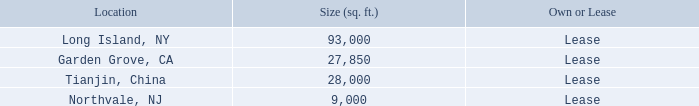Item 2. Properties
The Company operates out of several facilities located around the world. Each facility is used for manufacturing its products and for administrative activities. The following table presents the location, size and terms of ownership/occupation:
The Company’s facility located in Mitchel Field, Long Island, New York, is part of the building that the Company constructed in 1981 and expanded in 1988 on land leased from Nassau County. In January 1998, the Company sold this building and the related land lease to Reckson Associates Realty Corp. (“Reckson”), leasing back the space that it presently occupies.
The Company leased its manufacturing and office space from Reckson under an initial 11-year lease followed by two five-year renewal periods which ended in January 2019. On July 25, 2018, the Company signed an amendment to the lease with RA 55 CLB LLC (as successor-in-interest to Reckson) which extended the current lease terms ten years and eight months through September 30, 2029. Pursuant to the amendment to the lease agreement, the Company shall pay a gradually increasing annual rent of $1,046,810 in 2019 to $1,276,056 in 2029. The Company believes the leased space is adequate to meet the Company’s domestic operational needs which encompass the principal operations of the FEI-NY segment and also serves as the Company’s world-wide corporate headquarters.
The Garden Grove, California facility is leased by the Company’s subsidiary, FEI-Zyfer. The facility consists of a combination office and manufacturing space. The Company has signed a second amendment to the lease, which extends the lease an additional 88 months, beginning October 1, 2017 and expiring January 31, 2025. The average annual rent over the period of the amendment is approximately $312,000. The Company believes the leased space is adequate to meet FEI-Zyfer’s operational needs.
The Tianjin, China facility is the location of the Company’s wholly-owned subsidiary, FEI-Asia. The subsidiary’s office and manufacturing facility is located in the Tianjin Free-Trade Zone. The lease was renewable annually with monthly rent of $8,500 through August 2019. As mentioned in Footnote 3, below, FEI-Asia was sold on May 21, 2019 and as a result the lease commitment transferred with the sale.
FEI-Elcom entered into a new lease agreement on February 1, 2018 regarding its Northvale, New Jersey facility. The facility consists of a combination office and manufacturing space. The lease, which expires in January 31, 2021, requires monthly payments of $9,673. The Company believes the leased space is adequate to meet FEI-Elcom’s operational needs.
What is the size of the Long Island, NY and Garden Grove, CA facilities respectively in sq ft? 93,000, 27,850. What is the size of the Tianjin, China and Northvale, NJ facilities respectively in sq ft? 28,000, 9,000. When did the company enter into a new lease agreement for its Northvale, New Jersey facility? February 1, 2018. What is the difference in size between the Long Island, NY and Northvale, NJ facility in sq ft? 93,000-9,000
Answer: 84000. How many facilities are currently under lease? Long Island, NY ## Garden Grove, CA ## Tianjin, China ## Northvale, NJ
Answer: 4. What is the total size of all the four facilities leased by the company in sq ft? 93,000+27,850+28,000+9,000
Answer: 157850. 